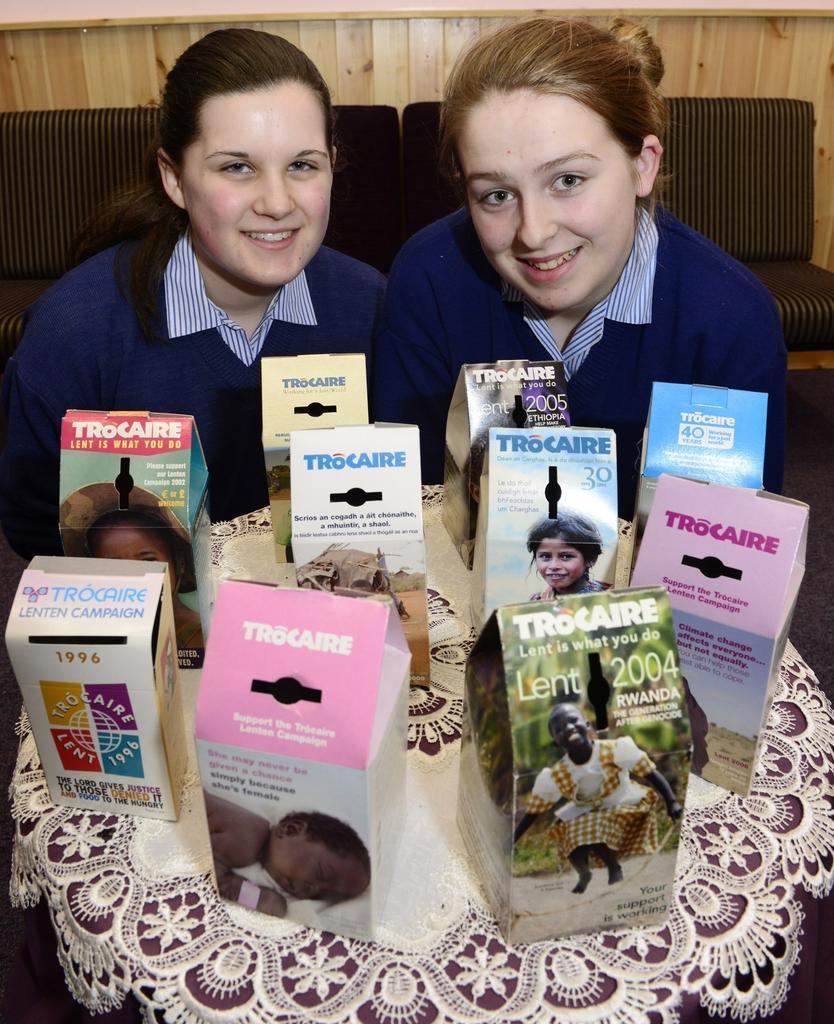How would you summarize this image in a sentence or two? In this picture we can see two women, they both are smiling, in front of them we can see few boxes on the table. 